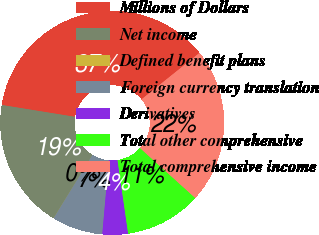Convert chart to OTSL. <chart><loc_0><loc_0><loc_500><loc_500><pie_chart><fcel>Millions of Dollars<fcel>Net income<fcel>Defined benefit plans<fcel>Foreign currency translation<fcel>Derivatives<fcel>Total other comprehensive<fcel>Total comprehensive income<nl><fcel>36.7%<fcel>18.78%<fcel>0.02%<fcel>7.35%<fcel>3.69%<fcel>11.02%<fcel>22.45%<nl></chart> 